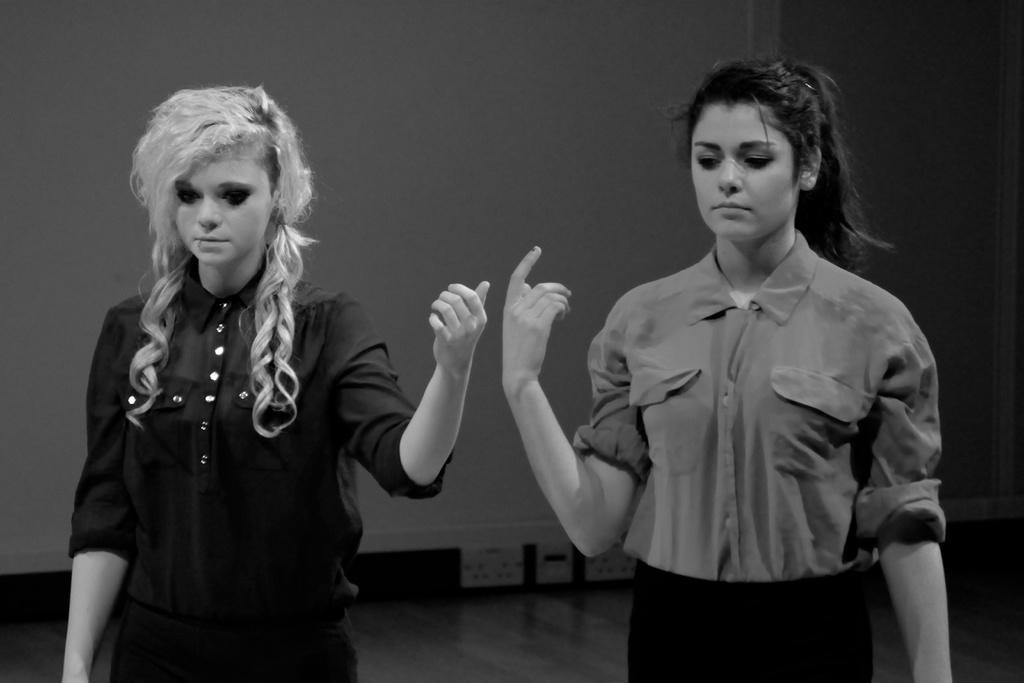Describe this image in one or two sentences. In this image I can see the black and white picture in which I can see a woman wearing black colored dress and another woman wearing shirt and black colored pant are standing. In the background I can see the wall and the floor. 